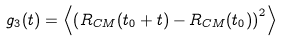<formula> <loc_0><loc_0><loc_500><loc_500>g _ { 3 } ( t ) = \left < \left ( R _ { C M } ( t _ { 0 } + t ) - R _ { C M } ( t _ { 0 } ) \right ) ^ { 2 } \right ></formula> 